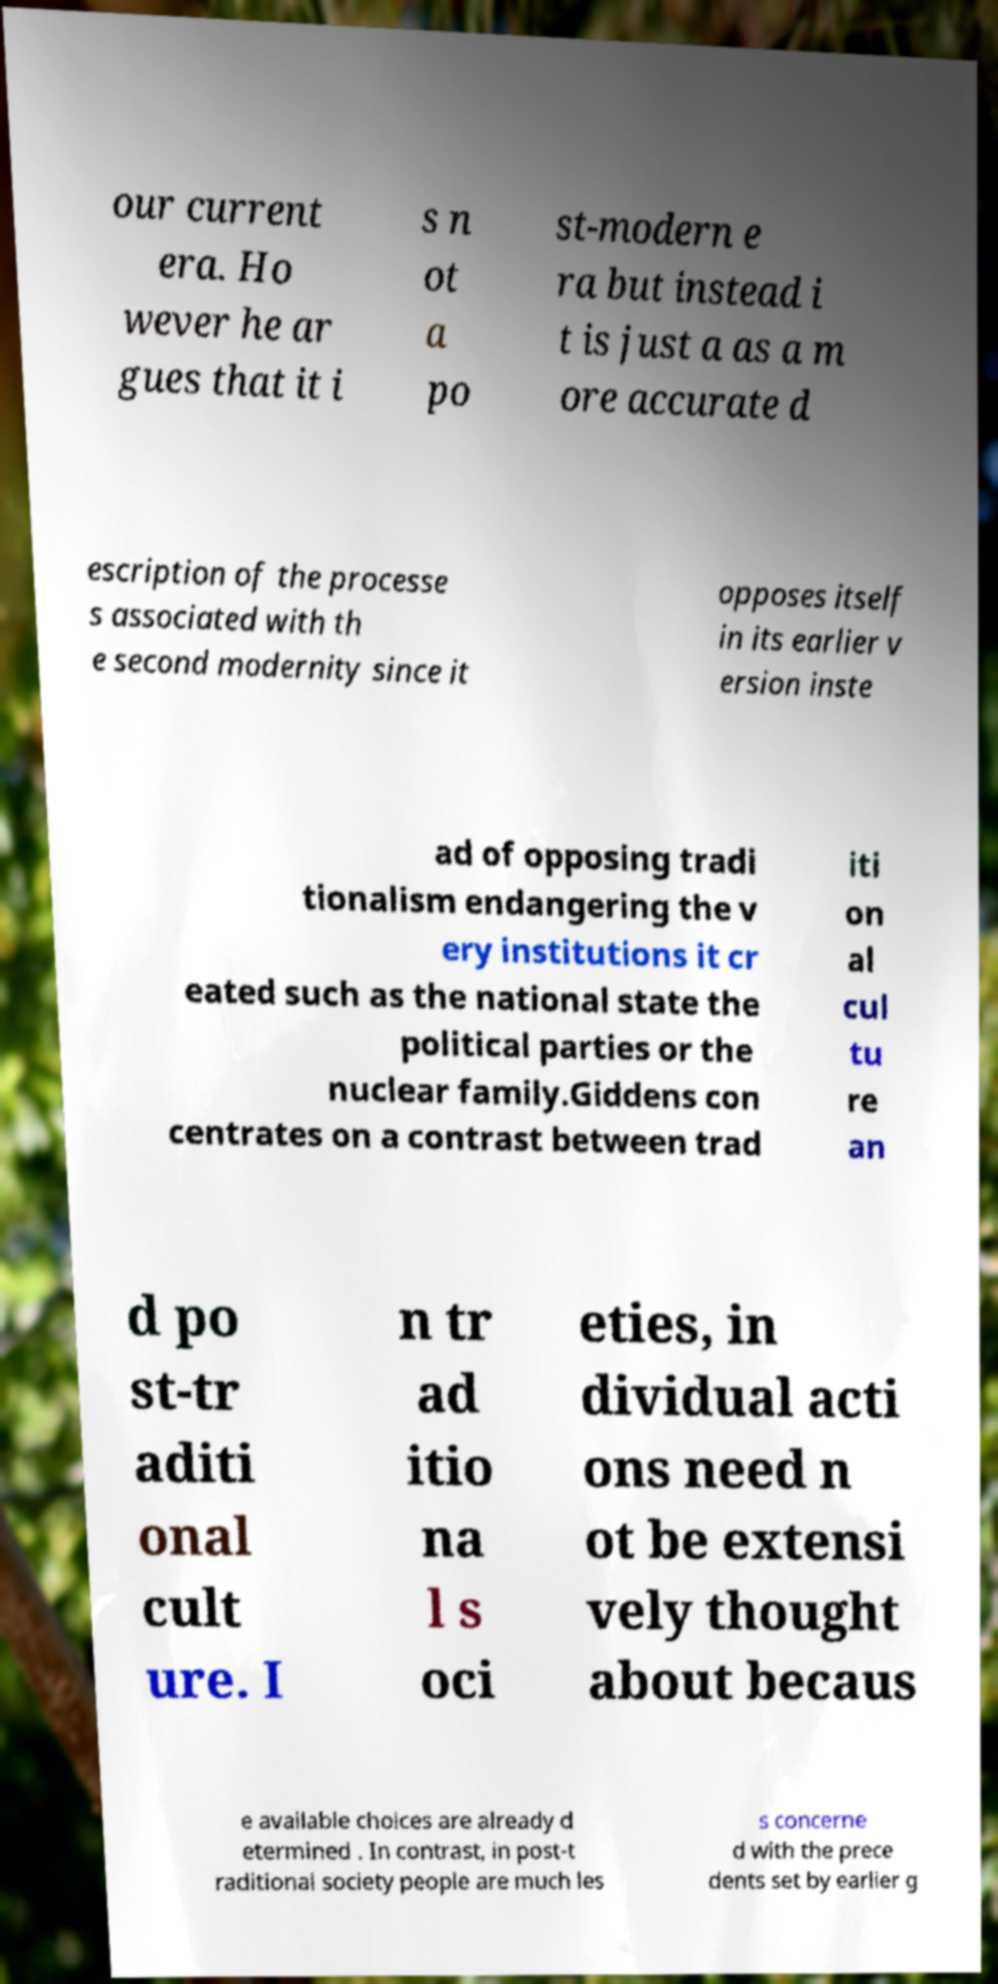There's text embedded in this image that I need extracted. Can you transcribe it verbatim? our current era. Ho wever he ar gues that it i s n ot a po st-modern e ra but instead i t is just a as a m ore accurate d escription of the processe s associated with th e second modernity since it opposes itself in its earlier v ersion inste ad of opposing tradi tionalism endangering the v ery institutions it cr eated such as the national state the political parties or the nuclear family.Giddens con centrates on a contrast between trad iti on al cul tu re an d po st-tr aditi onal cult ure. I n tr ad itio na l s oci eties, in dividual acti ons need n ot be extensi vely thought about becaus e available choices are already d etermined . In contrast, in post-t raditional society people are much les s concerne d with the prece dents set by earlier g 